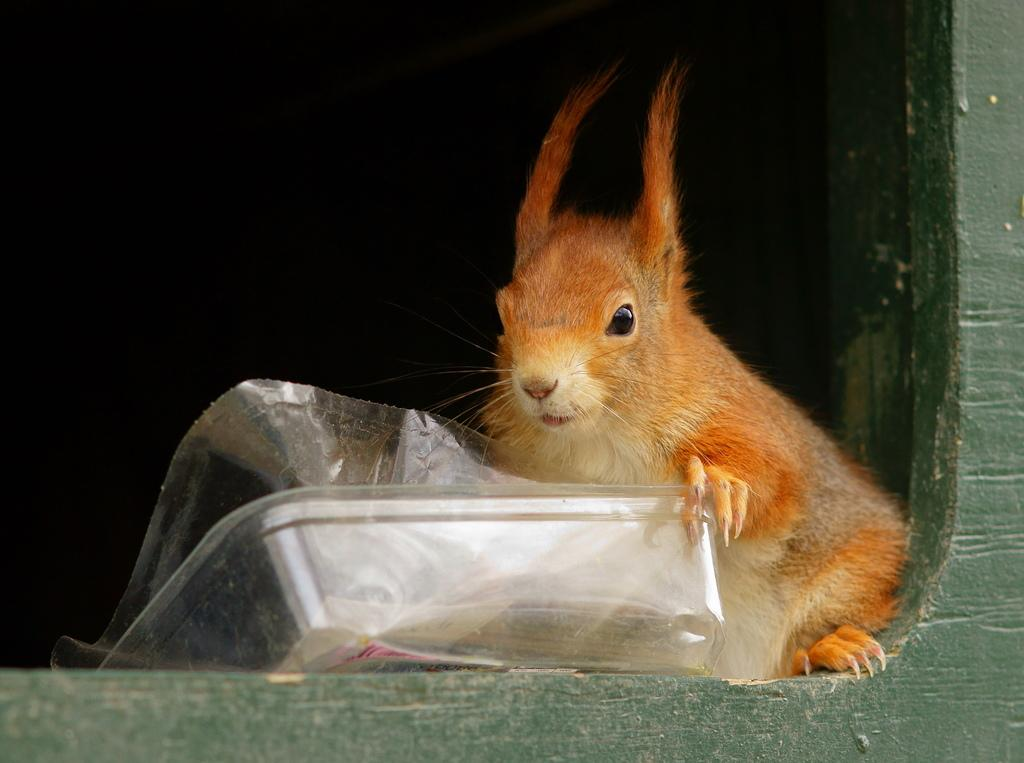What is the main subject in the center of the image? There is a squirrel in the center of the image. What else can be seen in the center of the image? There is a plastic wrapper in the center of the image. Can you describe the border of the image? The image appears to have a wooden border at the bottom side. How many sticks are the duck using to build a nest in the image? There is no duck or sticks present in the image. What type of wound can be seen on the squirrel in the image? There is no wound visible on the squirrel in the image. 